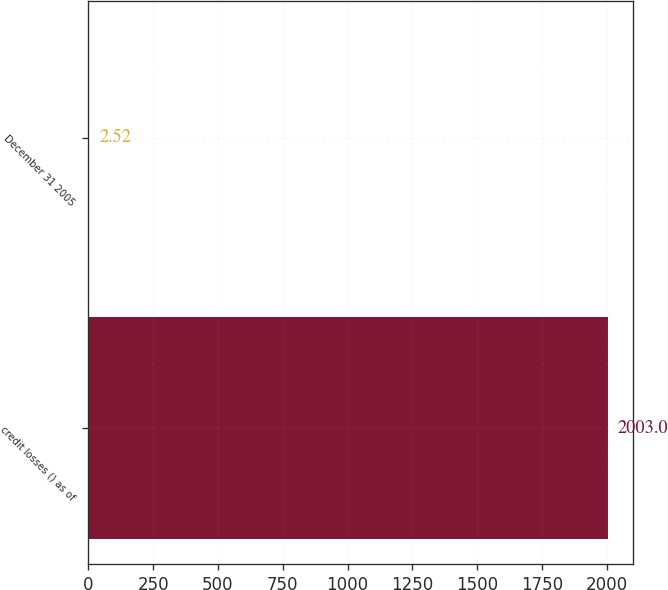<chart> <loc_0><loc_0><loc_500><loc_500><bar_chart><fcel>credit losses () as of<fcel>December 31 2005<nl><fcel>2003<fcel>2.52<nl></chart> 